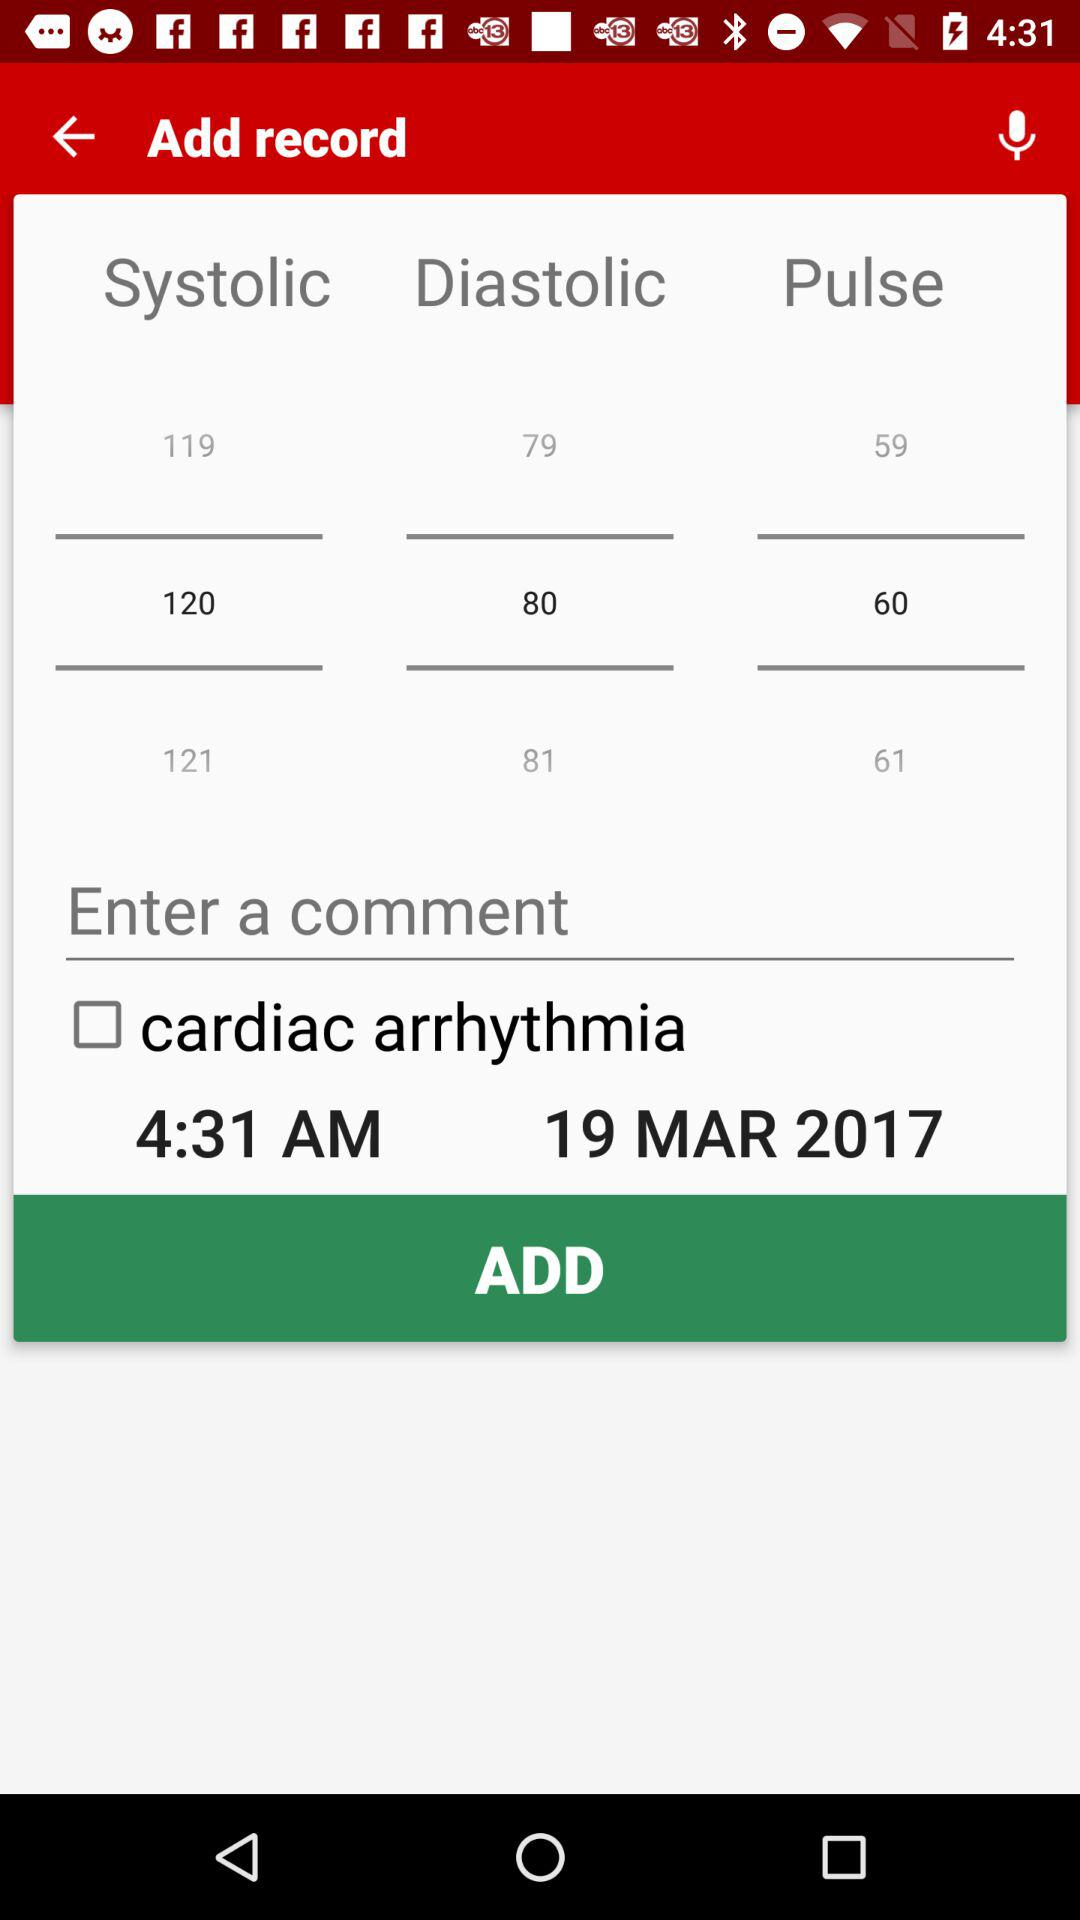Which date is mentioned on the screen? The date mentioned on the screen is March 19, 2017. 